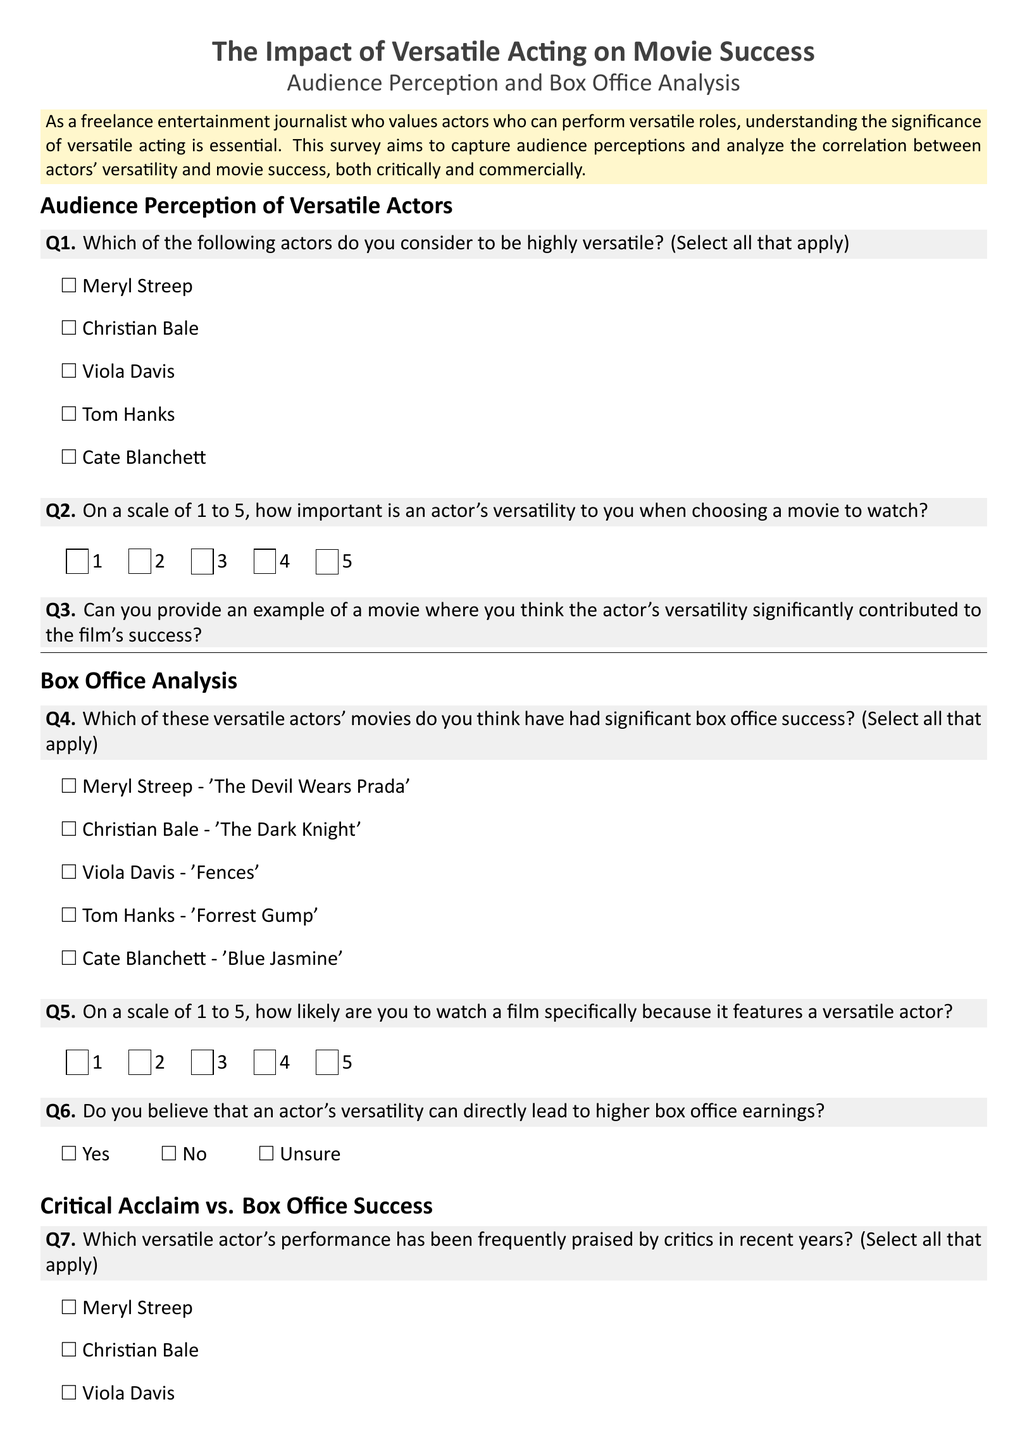What is the title of the survey? The title is prominently displayed at the top of the document and is "The Impact of Versatile Acting on Movie Success."
Answer: The Impact of Versatile Acting on Movie Success Who are some actors considered to be highly versatile according to the survey? The survey lists actors who are considered versatile, including Meryl Streep, Christian Bale, Viola Davis, Tom Hanks, and Cate Blanchett.
Answer: Meryl Streep, Christian Bale, Viola Davis, Tom Hanks, Cate Blanchett On a scale of 1 to 5, what question is asked about the importance of an actor's versatility? The question asks respondents to rate how important an actor's versatility is when choosing a movie to watch on a scale of 1 to 5.
Answer: Importance rating What example does the survey ask for regarding movies and versatile acting? The survey requests an example of a movie where the actor's versatility significantly contributed to the film's success.
Answer: Example of a movie Which actor's performance has been frequently praised by critics according to question 7? The survey asks participants to select versatile actors frequently praised by critics, including Meryl Streep, Christian Bale, Viola Davis, Tom Hanks, and Cate Blanchett.
Answer: Meryl Streep, Christian Bale, Viola Davis, Tom Hanks, Cate Blanchett What options are provided for respondents to indicate their belief about actors' versatility leading to box office earnings? The options provided are "Yes," "No," and "Unsure" to gauge belief in the impact of versatility on box office earnings.
Answer: Yes, No, Unsure How many actors can participants select in question 1? The question allows respondents to select all actors they consider to be highly versatile, implying multiple selections.
Answer: All that apply What box office success movie is associated with Tom Hanks? The survey includes 'Forrest Gump' as a significant box office success associated with Tom Hanks.
Answer: Forrest Gump 